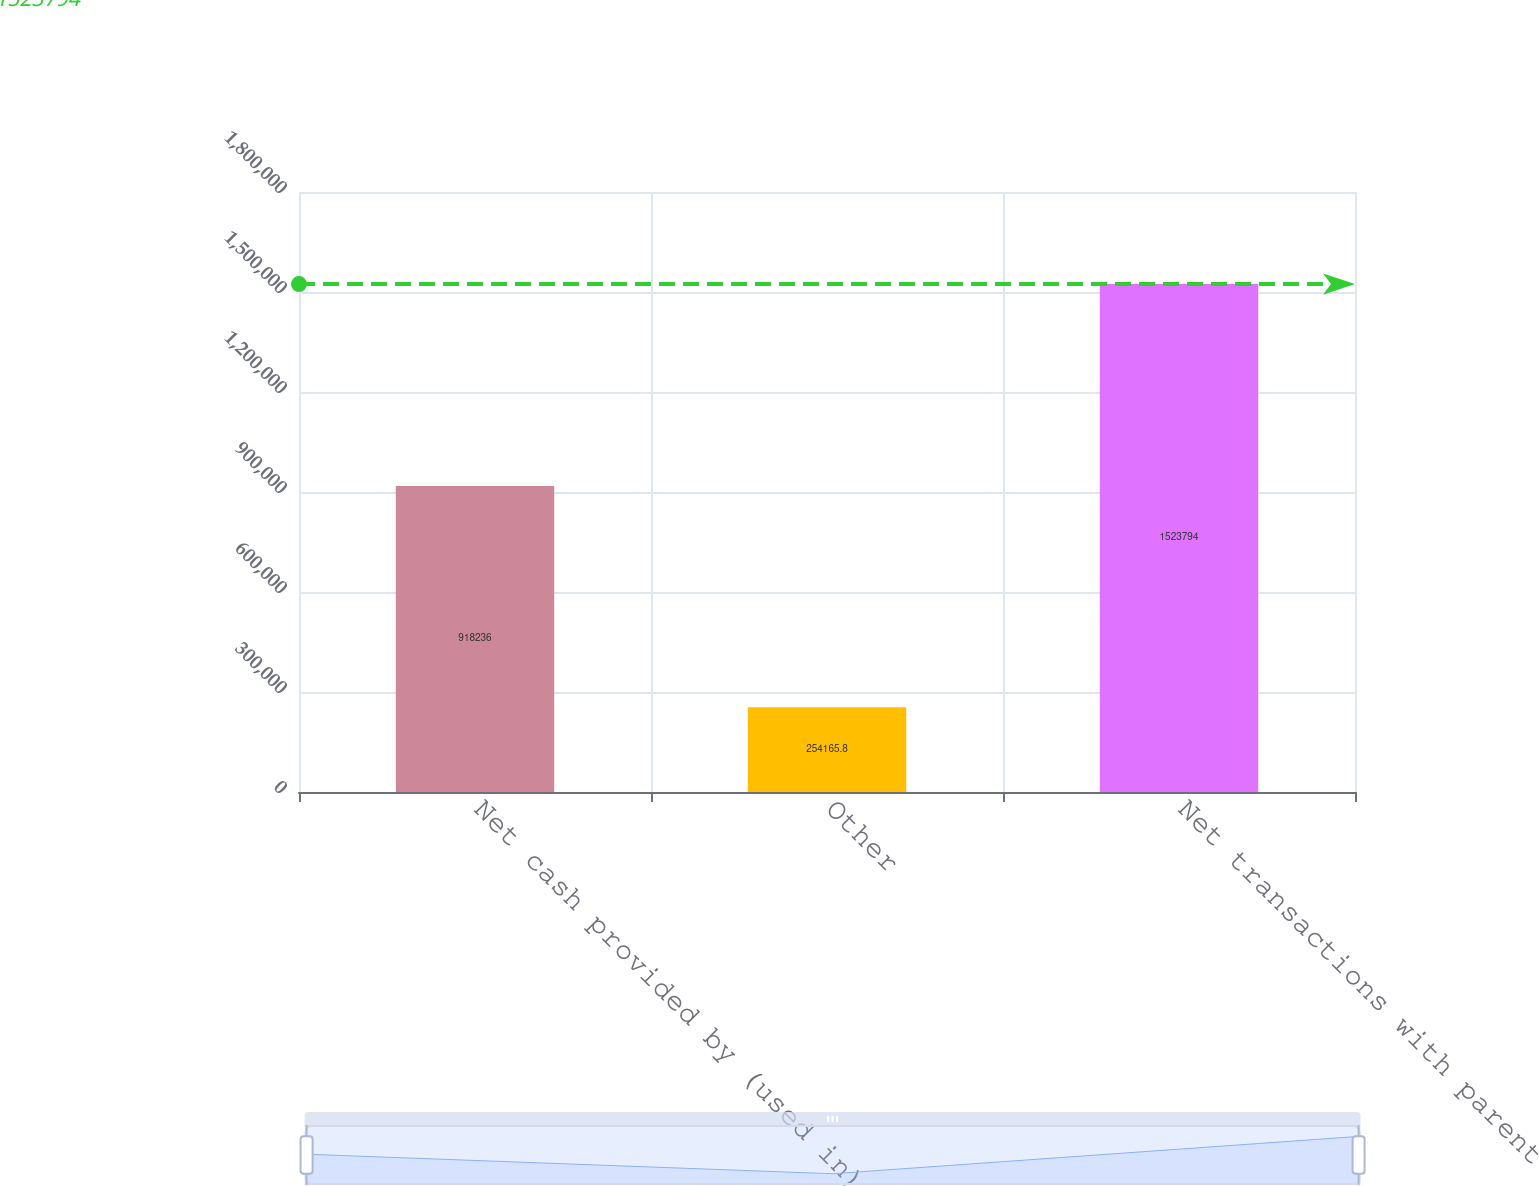Convert chart to OTSL. <chart><loc_0><loc_0><loc_500><loc_500><bar_chart><fcel>Net cash provided by (used in)<fcel>Other<fcel>Net transactions with parent<nl><fcel>918236<fcel>254166<fcel>1.52379e+06<nl></chart> 